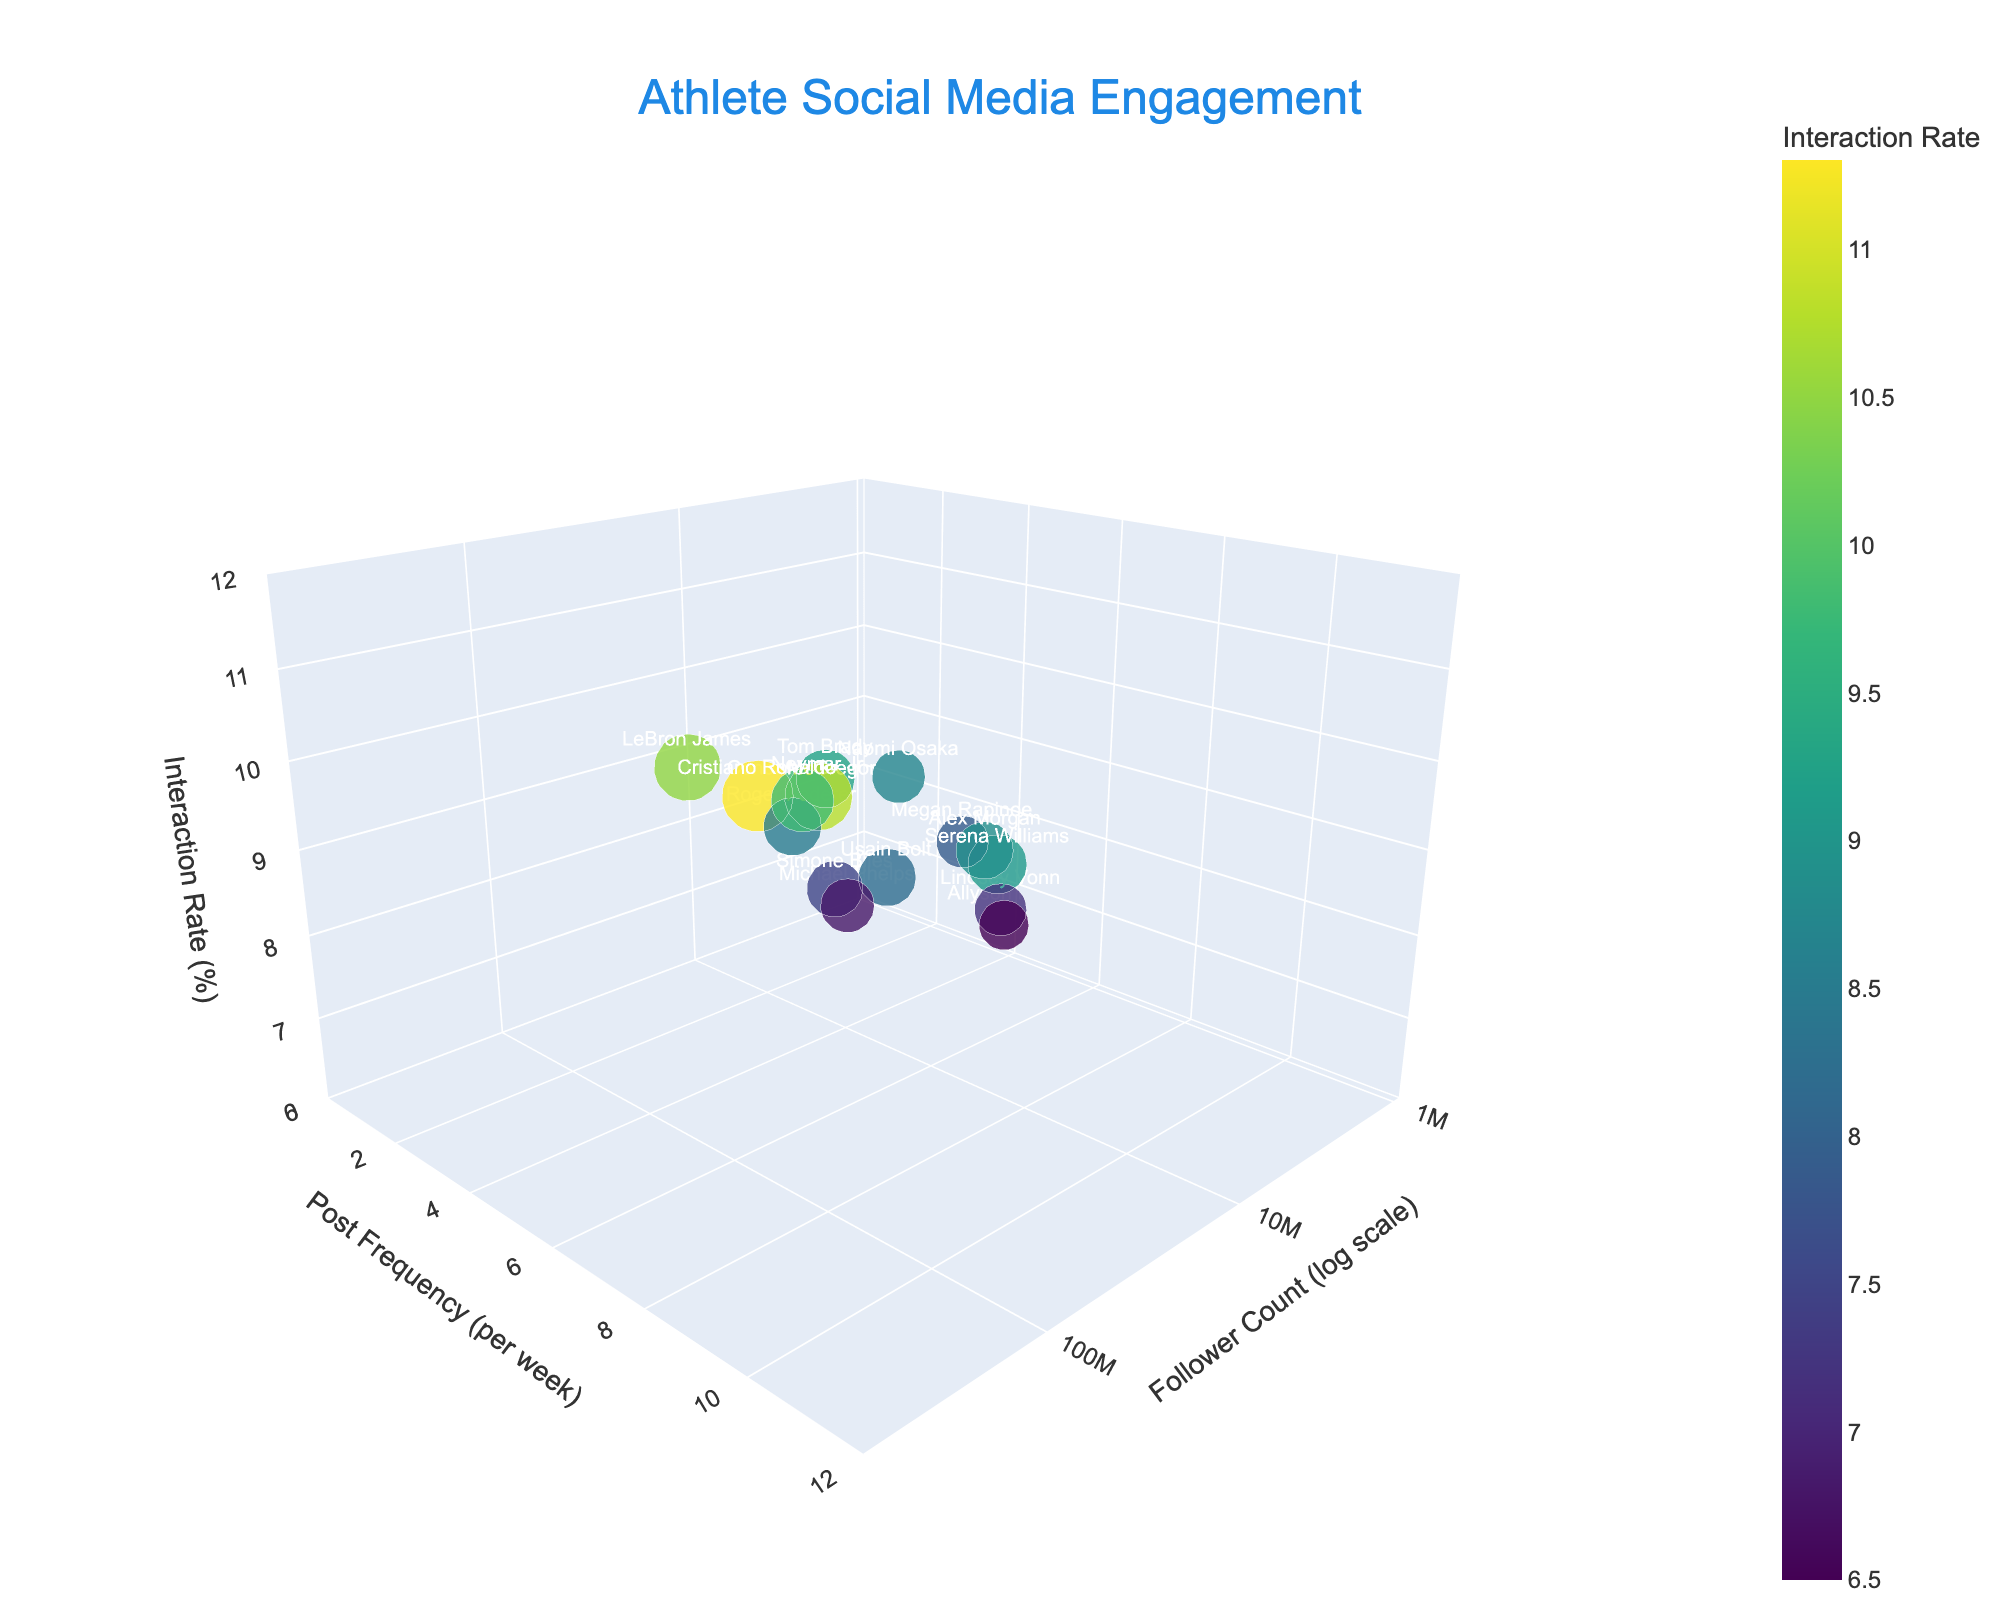What is the title of the figure? The title can be seen at the top of the figure. It summarizes the content of the plot, helping us understand what the visual data represents.
Answer: Athlete Social Media Engagement How many athletes are represented in the plot? By counting the data points in the 3D plot, each point representing an athlete, we can find the total number of athletes.
Answer: 15 Which athlete has the highest follower count? By looking at the x-axis (Follower Count), we find the data point farthest to the right and identify the corresponding athlete label.
Answer: Cristiano Ronaldo What is the relationship between post frequency and interaction rate for Cristiano Ronaldo compared to Neymar Jr? To answer this, check the y-axis (Post Frequency) and z-axis (Interaction Rate) values for both Cristiano Ronaldo and Neymar Jr, then compare them.
Answer: Cristiano Ronaldo has a higher interaction rate and lower post frequency compared to Neymar Jr Which athlete has the lowest interaction rate, and what is that rate? Find the data point with the smallest value on the z-axis (Interaction Rate) and read the corresponding label and value.
Answer: Allyson Felix, 6.5 Who has a follower count between 5,000,000 and 20,000,000 and an interaction rate above 9%? Filter the athletes by checking the x-axis for follower count between these values and the z-axis for interaction rates above 9%, then find the corresponding data points.
Answer: Serena Williams, Tom Brady What is the average post frequency of athletes with an interaction rate above 9%? Identify athletes with interaction rates above 9%, sum their post frequencies from the y-axis values, then divide by the number of these athletes.
Answer: (8 + 4 + 6 + 9 + 10 + 7) / 6 = 7.33 Which athlete with a follower count less than 10,000,000 has the highest interaction rate? First filter athletes by x-axis (Follower Count) less than 10,000,000, then compare their z-axis (Interaction Rate) values, and identify the highest.
Answer: Alex Morgan How does Usain Bolt's engagement compare to LeBron James in terms of interaction rate and post frequency? Compare the y-axis (Post Frequency) and z-axis (Interaction Rate) values of both athletes.
Answer: Usain Bolt has a lower interaction rate and post frequency compared to LeBron James What is the median follower count of all the athletes? Order the follower counts listed on the x-axis, find the middle value or the average of the two middle values if the total number of data points is even.
Answer: Median of [1100000, 2100000, 2200000, 2900000, 3400000, 6800000, 9800000, 10200000, 11500000, 12700000, 15600000, 45600000, 141000000, 178000000, 485000000] = 10200000 